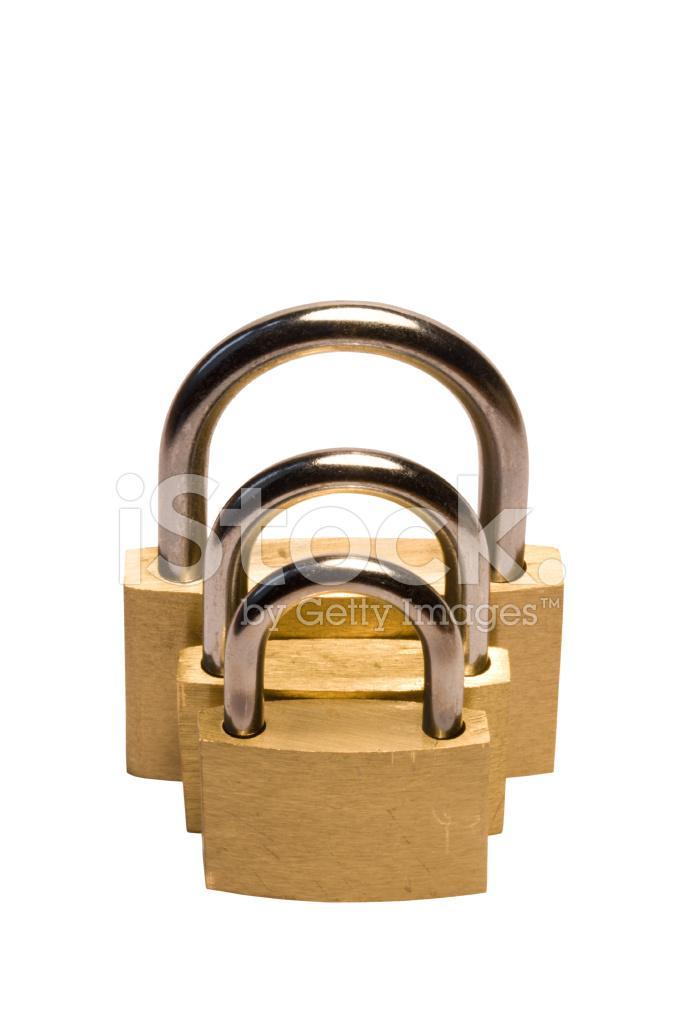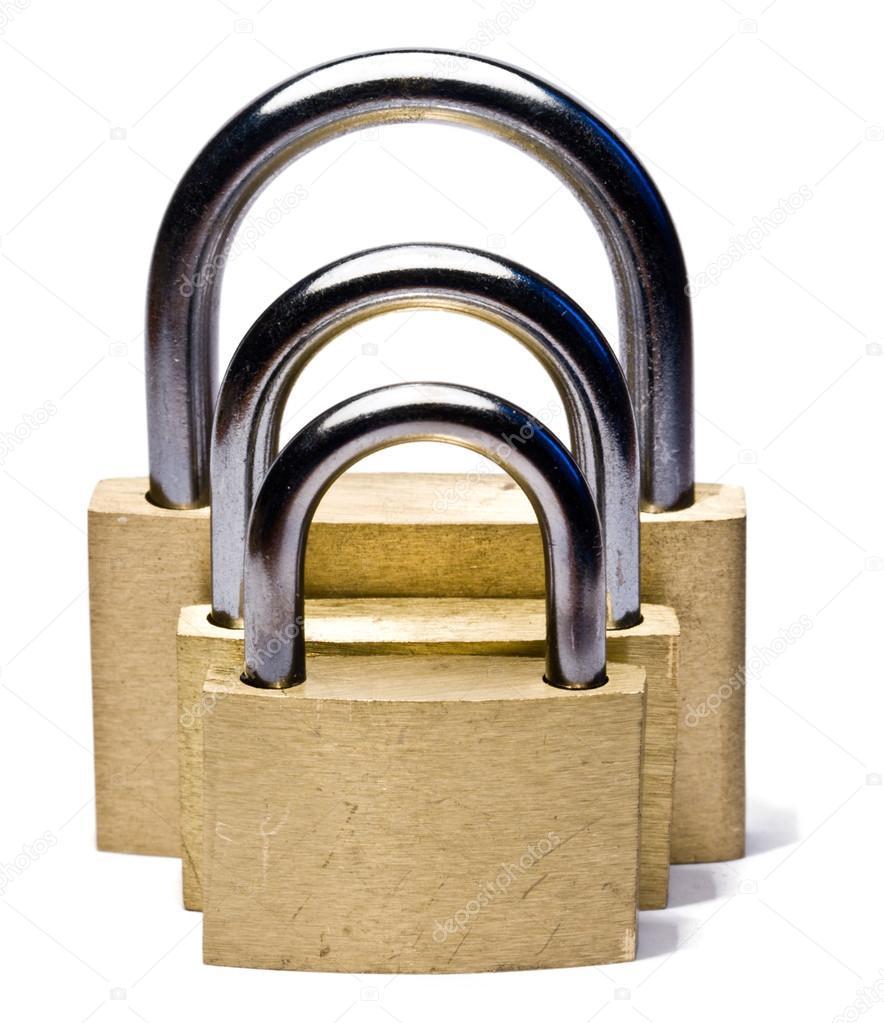The first image is the image on the left, the second image is the image on the right. For the images displayed, is the sentence "A ring holding three keys is next to a padlock in one image." factually correct? Answer yes or no. No. The first image is the image on the left, the second image is the image on the right. Examine the images to the left and right. Is the description "There is a single set of keys with the locks." accurate? Answer yes or no. No. 